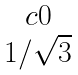Convert formula to latex. <formula><loc_0><loc_0><loc_500><loc_500>\begin{matrix} { c } 0 \\ { 1 / \sqrt { 3 } } \end{matrix}</formula> 